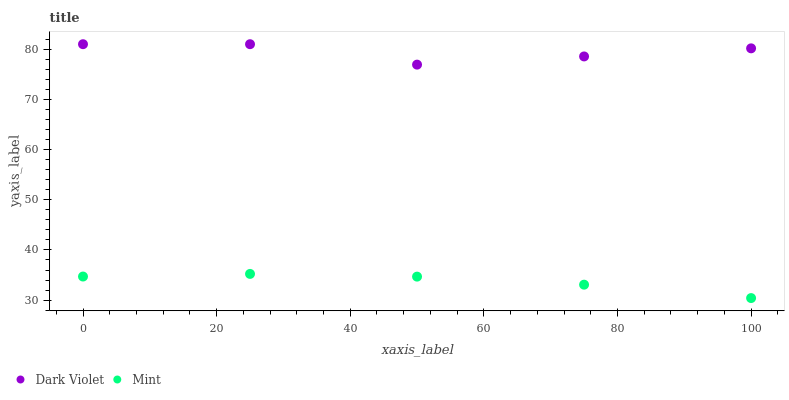Does Mint have the minimum area under the curve?
Answer yes or no. Yes. Does Dark Violet have the maximum area under the curve?
Answer yes or no. Yes. Does Dark Violet have the minimum area under the curve?
Answer yes or no. No. Is Mint the smoothest?
Answer yes or no. Yes. Is Dark Violet the roughest?
Answer yes or no. Yes. Is Dark Violet the smoothest?
Answer yes or no. No. Does Mint have the lowest value?
Answer yes or no. Yes. Does Dark Violet have the lowest value?
Answer yes or no. No. Does Dark Violet have the highest value?
Answer yes or no. Yes. Is Mint less than Dark Violet?
Answer yes or no. Yes. Is Dark Violet greater than Mint?
Answer yes or no. Yes. Does Mint intersect Dark Violet?
Answer yes or no. No. 